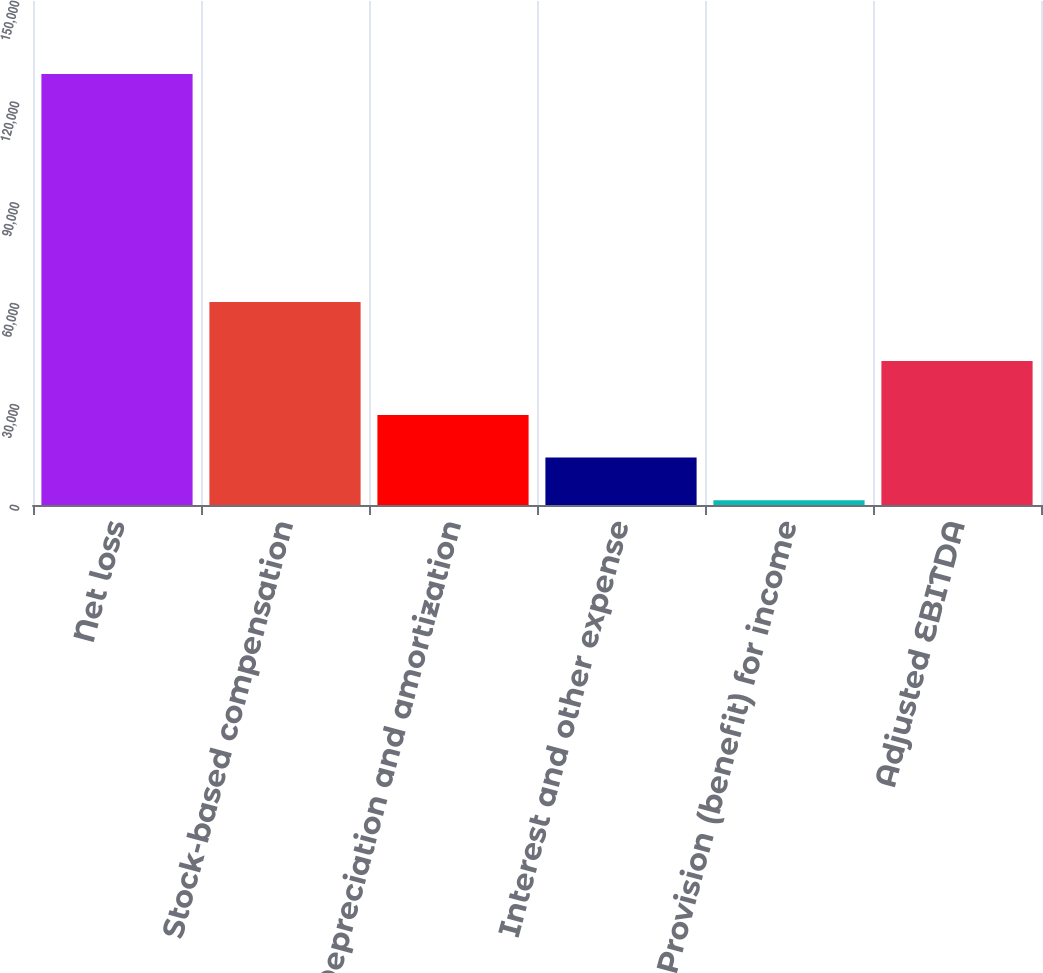Convert chart. <chart><loc_0><loc_0><loc_500><loc_500><bar_chart><fcel>Net loss<fcel>Stock-based compensation<fcel>Depreciation and amortization<fcel>Interest and other expense<fcel>Provision (benefit) for income<fcel>Adjusted EBITDA<nl><fcel>128302<fcel>60384<fcel>26815.6<fcel>14129.8<fcel>1444<fcel>42835<nl></chart> 